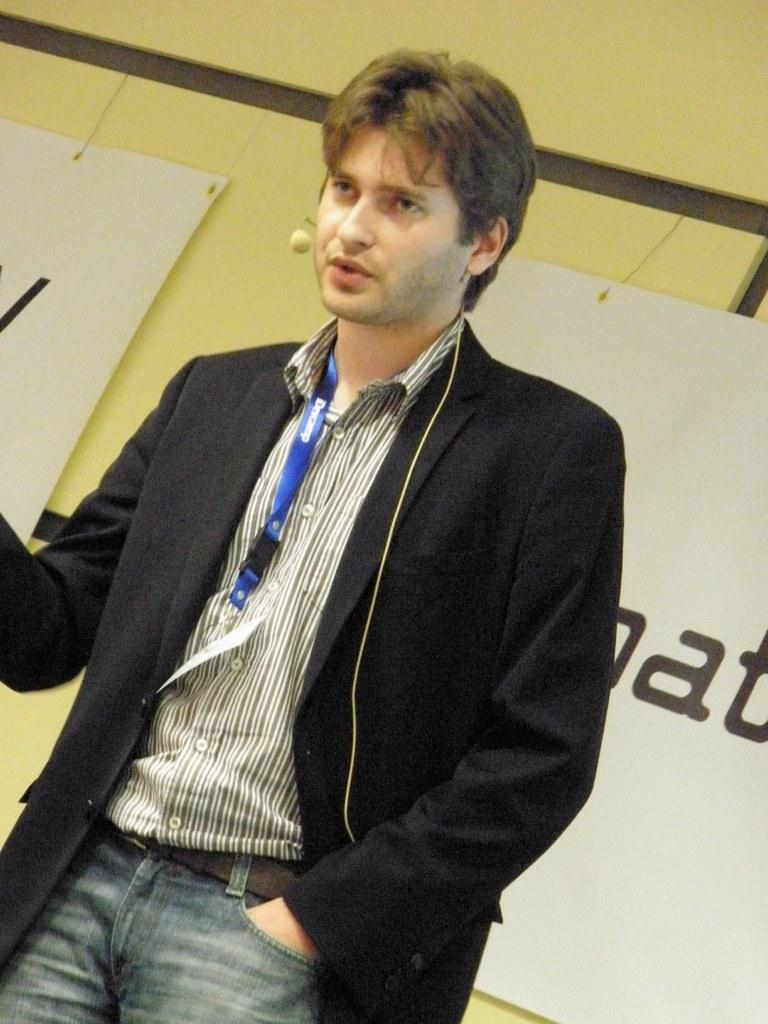Who is present in the image? There is a man in the image. What is the man wearing? The man is wearing a suit. What can be seen in the background of the image? There are banners and a wall in the background of the image. How many sheep are visible in the image? There are no sheep present in the image. What type of things can be seen floating in the air in the image? There is no indication of any things floating in the air in the image. 